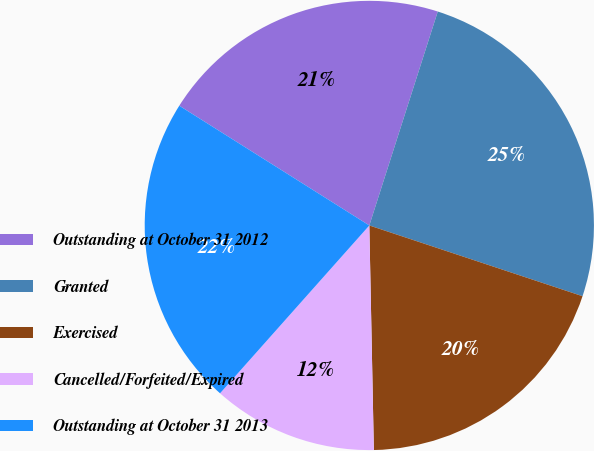Convert chart to OTSL. <chart><loc_0><loc_0><loc_500><loc_500><pie_chart><fcel>Outstanding at October 31 2012<fcel>Granted<fcel>Exercised<fcel>Cancelled/Forfeited/Expired<fcel>Outstanding at October 31 2013<nl><fcel>20.98%<fcel>25.17%<fcel>19.58%<fcel>11.89%<fcel>22.38%<nl></chart> 